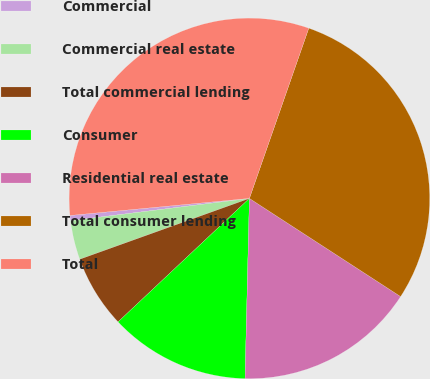Convert chart. <chart><loc_0><loc_0><loc_500><loc_500><pie_chart><fcel>Commercial<fcel>Commercial real estate<fcel>Total commercial lending<fcel>Consumer<fcel>Residential real estate<fcel>Total consumer lending<fcel>Total<nl><fcel>0.47%<fcel>3.5%<fcel>6.53%<fcel>12.6%<fcel>16.22%<fcel>28.82%<fcel>31.85%<nl></chart> 